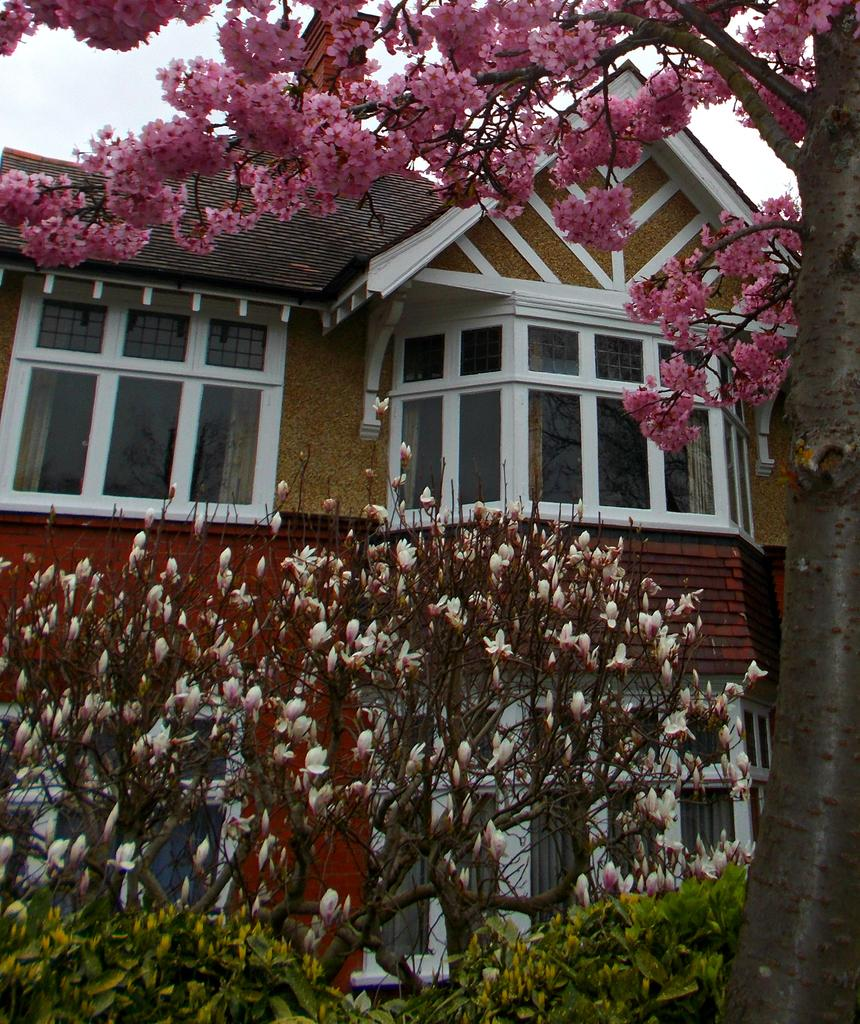What type of structure is present in the image? There is a building in the image. What is located in front of the building? There are trees, plants, and flowers in front of the building. What can be seen in the background of the image? The sky is visible in the background of the image. How many children are riding in the carriage in the image? There is no carriage present in the image. 